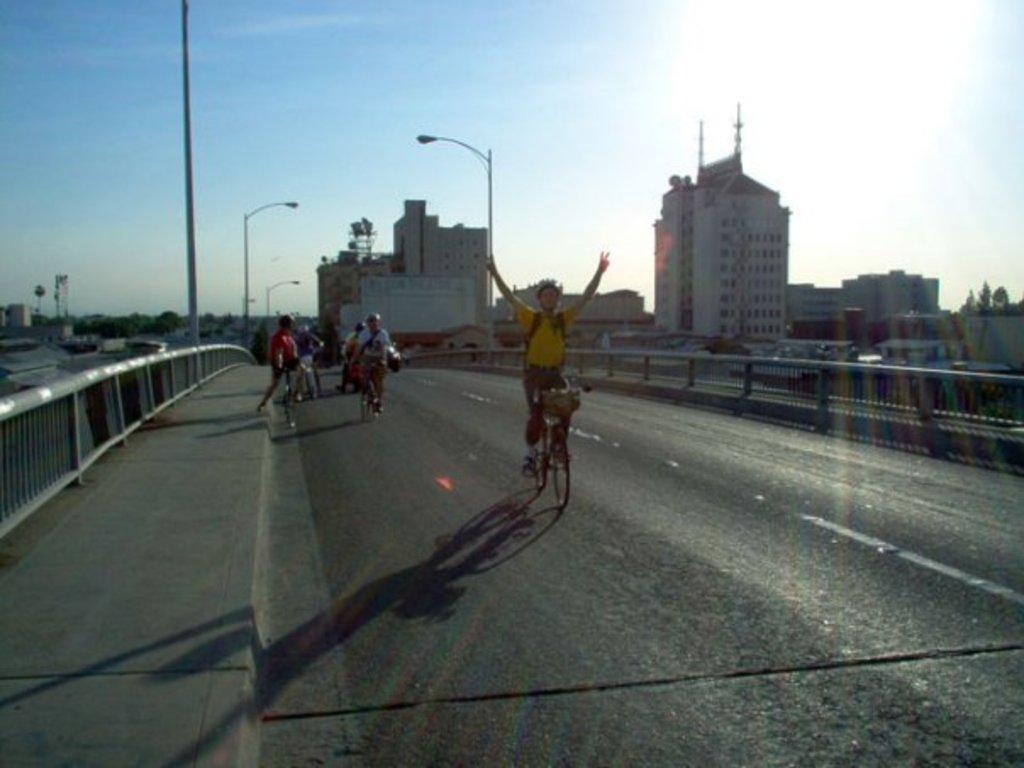How would you summarize this image in a sentence or two? In this image we can see few people riding bicycles on the road. There are few road safety barriers in the image. There are many buildings in the image. There are few street lights in the image. We can see the sky in the image. 